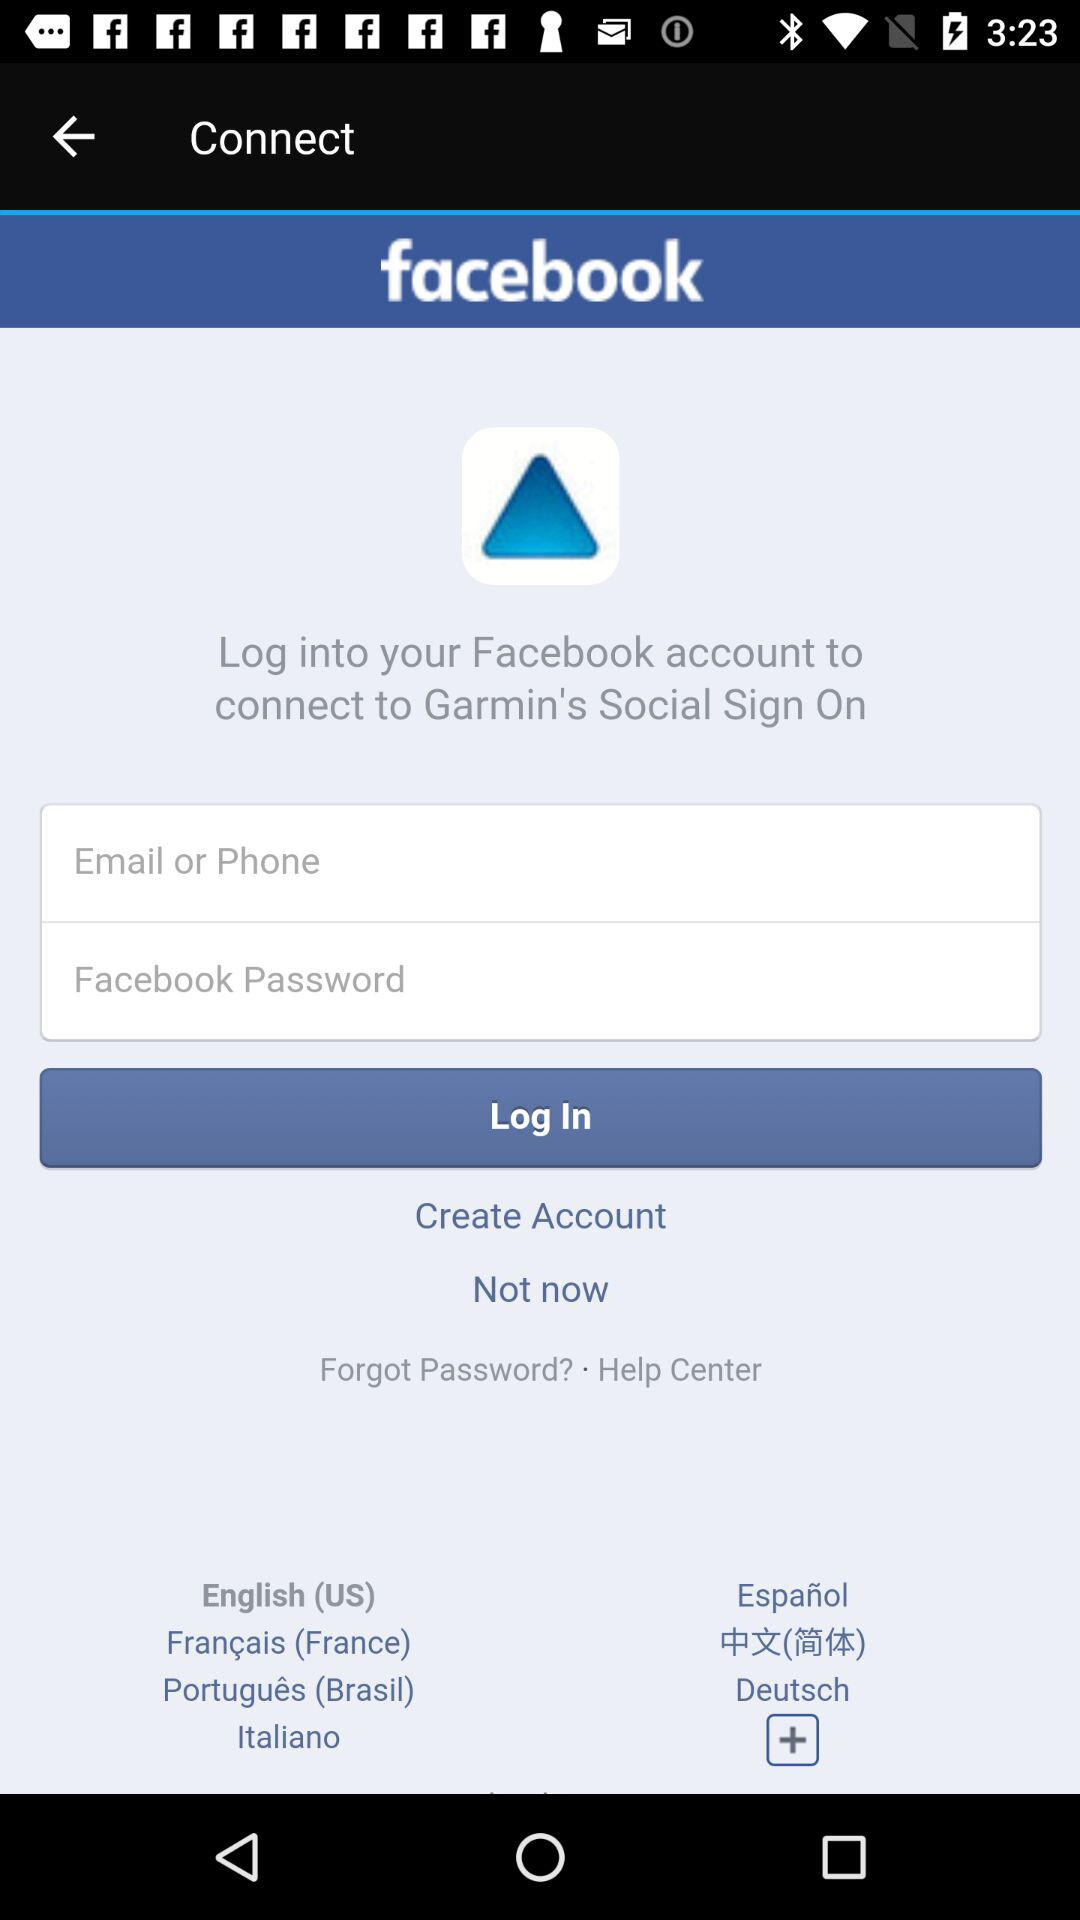How many languages are available for selection on this screen?
Answer the question using a single word or phrase. 7 